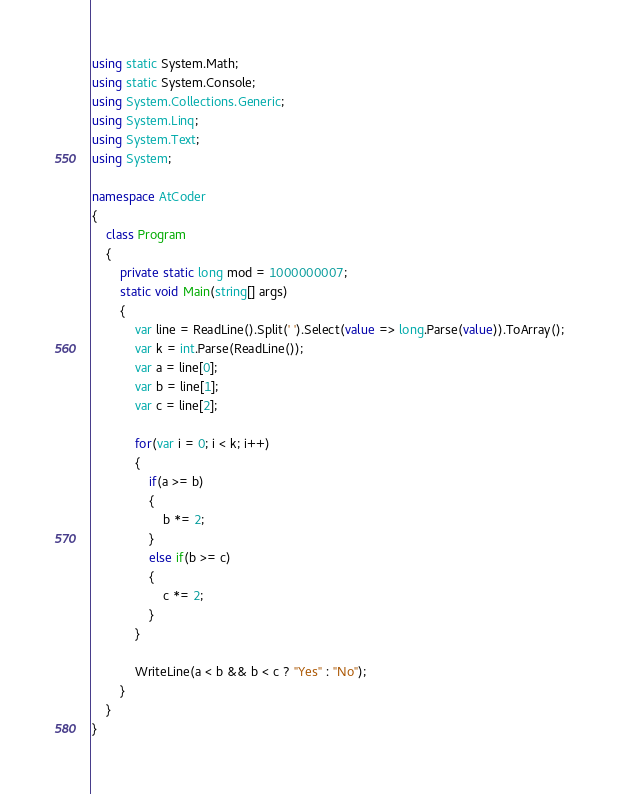Convert code to text. <code><loc_0><loc_0><loc_500><loc_500><_C#_>using static System.Math;
using static System.Console;
using System.Collections.Generic;
using System.Linq;
using System.Text;
using System;

namespace AtCoder
{
    class Program
    {
        private static long mod = 1000000007;
        static void Main(string[] args)
        {
            var line = ReadLine().Split(' ').Select(value => long.Parse(value)).ToArray();
            var k = int.Parse(ReadLine());
            var a = line[0];
            var b = line[1];
            var c = line[2];

            for(var i = 0; i < k; i++)
            {
                if(a >= b)
                {
                    b *= 2;
                }
                else if(b >= c)
                {
                    c *= 2;
                }
            }

            WriteLine(a < b && b < c ? "Yes" : "No");
        }
    }
}
</code> 